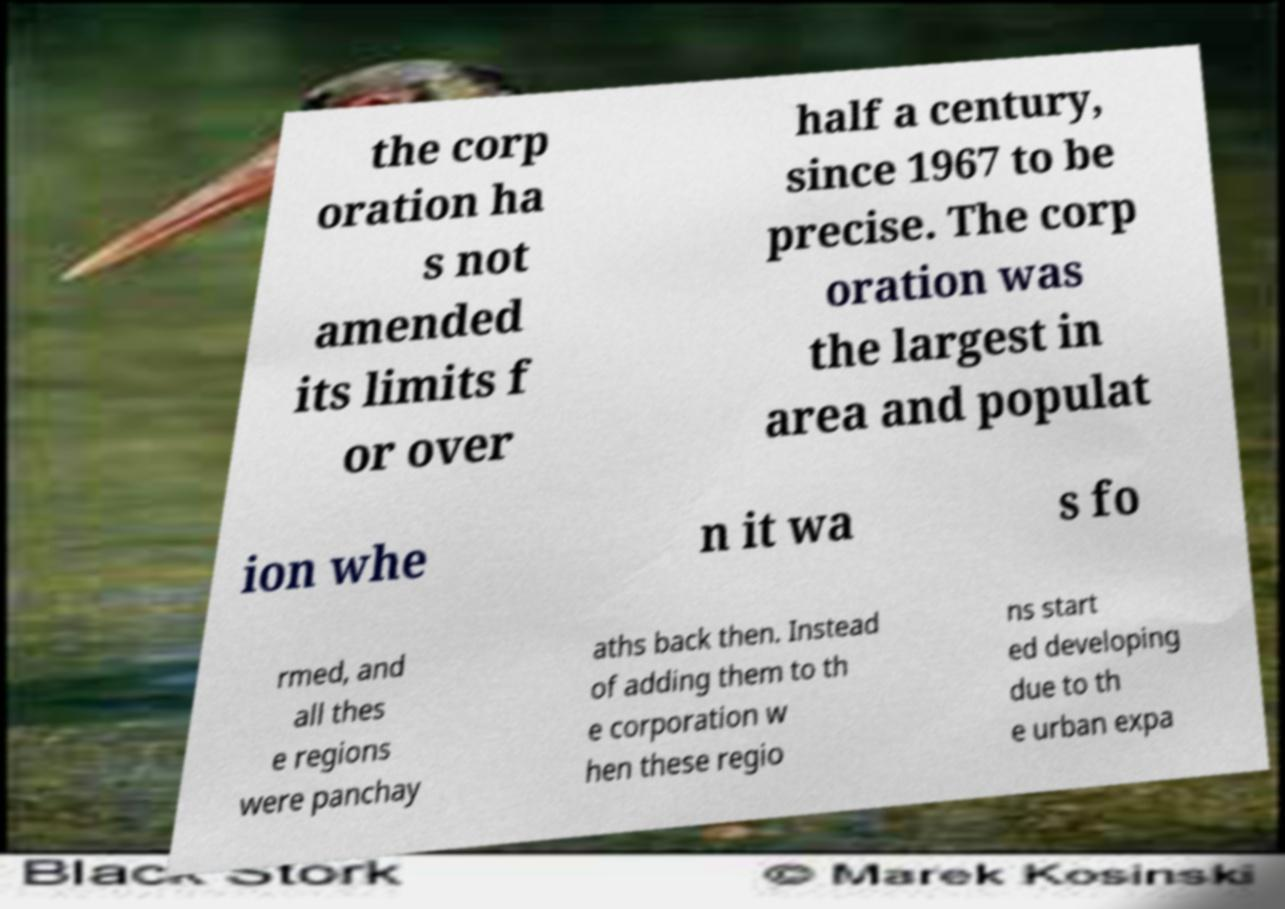For documentation purposes, I need the text within this image transcribed. Could you provide that? the corp oration ha s not amended its limits f or over half a century, since 1967 to be precise. The corp oration was the largest in area and populat ion whe n it wa s fo rmed, and all thes e regions were panchay aths back then. Instead of adding them to th e corporation w hen these regio ns start ed developing due to th e urban expa 